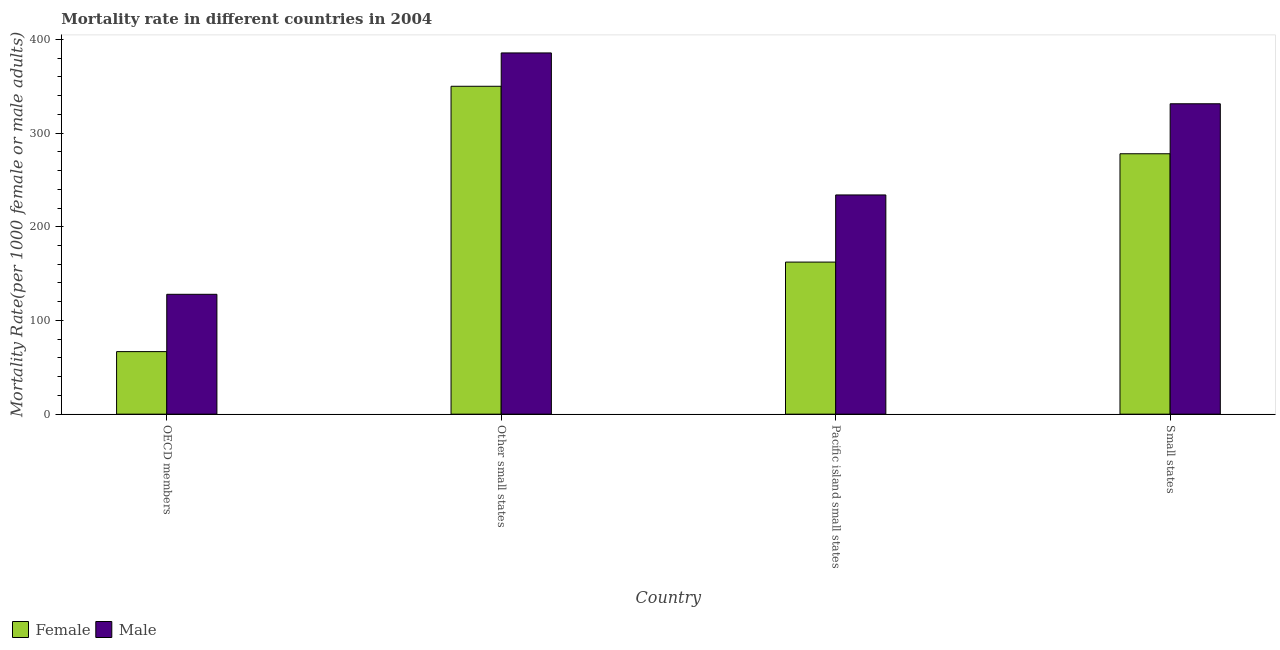How many different coloured bars are there?
Give a very brief answer. 2. How many groups of bars are there?
Provide a succinct answer. 4. Are the number of bars on each tick of the X-axis equal?
Your answer should be very brief. Yes. How many bars are there on the 2nd tick from the left?
Your answer should be compact. 2. How many bars are there on the 1st tick from the right?
Offer a terse response. 2. What is the label of the 4th group of bars from the left?
Your answer should be compact. Small states. What is the male mortality rate in Small states?
Offer a terse response. 331.24. Across all countries, what is the maximum female mortality rate?
Your answer should be very brief. 349.9. Across all countries, what is the minimum female mortality rate?
Your answer should be compact. 66.75. In which country was the female mortality rate maximum?
Ensure brevity in your answer.  Other small states. In which country was the male mortality rate minimum?
Your answer should be very brief. OECD members. What is the total male mortality rate in the graph?
Keep it short and to the point. 1078.55. What is the difference between the male mortality rate in OECD members and that in Small states?
Your answer should be very brief. -203.34. What is the difference between the female mortality rate in Small states and the male mortality rate in Pacific island small states?
Your answer should be very brief. 43.97. What is the average female mortality rate per country?
Make the answer very short. 214.21. What is the difference between the male mortality rate and female mortality rate in Pacific island small states?
Offer a terse response. 71.63. What is the ratio of the female mortality rate in OECD members to that in Pacific island small states?
Give a very brief answer. 0.41. Is the difference between the male mortality rate in Pacific island small states and Small states greater than the difference between the female mortality rate in Pacific island small states and Small states?
Ensure brevity in your answer.  Yes. What is the difference between the highest and the second highest female mortality rate?
Provide a succinct answer. 72.01. What is the difference between the highest and the lowest female mortality rate?
Offer a very short reply. 283.15. In how many countries, is the female mortality rate greater than the average female mortality rate taken over all countries?
Your answer should be very brief. 2. Is the sum of the male mortality rate in Other small states and Small states greater than the maximum female mortality rate across all countries?
Provide a short and direct response. Yes. What does the 1st bar from the right in Pacific island small states represents?
Your response must be concise. Male. Are all the bars in the graph horizontal?
Provide a short and direct response. No. How many countries are there in the graph?
Your response must be concise. 4. Are the values on the major ticks of Y-axis written in scientific E-notation?
Offer a very short reply. No. Does the graph contain grids?
Offer a very short reply. No. Where does the legend appear in the graph?
Your response must be concise. Bottom left. How are the legend labels stacked?
Ensure brevity in your answer.  Horizontal. What is the title of the graph?
Your answer should be very brief. Mortality rate in different countries in 2004. What is the label or title of the Y-axis?
Your answer should be very brief. Mortality Rate(per 1000 female or male adults). What is the Mortality Rate(per 1000 female or male adults) of Female in OECD members?
Your answer should be very brief. 66.75. What is the Mortality Rate(per 1000 female or male adults) of Male in OECD members?
Offer a very short reply. 127.9. What is the Mortality Rate(per 1000 female or male adults) of Female in Other small states?
Your response must be concise. 349.9. What is the Mortality Rate(per 1000 female or male adults) in Male in Other small states?
Your answer should be very brief. 385.48. What is the Mortality Rate(per 1000 female or male adults) of Female in Pacific island small states?
Provide a short and direct response. 162.3. What is the Mortality Rate(per 1000 female or male adults) in Male in Pacific island small states?
Ensure brevity in your answer.  233.93. What is the Mortality Rate(per 1000 female or male adults) in Female in Small states?
Provide a short and direct response. 277.9. What is the Mortality Rate(per 1000 female or male adults) in Male in Small states?
Make the answer very short. 331.24. Across all countries, what is the maximum Mortality Rate(per 1000 female or male adults) in Female?
Offer a very short reply. 349.9. Across all countries, what is the maximum Mortality Rate(per 1000 female or male adults) of Male?
Offer a terse response. 385.48. Across all countries, what is the minimum Mortality Rate(per 1000 female or male adults) of Female?
Provide a short and direct response. 66.75. Across all countries, what is the minimum Mortality Rate(per 1000 female or male adults) in Male?
Keep it short and to the point. 127.9. What is the total Mortality Rate(per 1000 female or male adults) of Female in the graph?
Keep it short and to the point. 856.85. What is the total Mortality Rate(per 1000 female or male adults) in Male in the graph?
Keep it short and to the point. 1078.55. What is the difference between the Mortality Rate(per 1000 female or male adults) of Female in OECD members and that in Other small states?
Make the answer very short. -283.15. What is the difference between the Mortality Rate(per 1000 female or male adults) of Male in OECD members and that in Other small states?
Make the answer very short. -257.58. What is the difference between the Mortality Rate(per 1000 female or male adults) of Female in OECD members and that in Pacific island small states?
Make the answer very short. -95.55. What is the difference between the Mortality Rate(per 1000 female or male adults) in Male in OECD members and that in Pacific island small states?
Your answer should be very brief. -106.03. What is the difference between the Mortality Rate(per 1000 female or male adults) in Female in OECD members and that in Small states?
Provide a succinct answer. -211.15. What is the difference between the Mortality Rate(per 1000 female or male adults) of Male in OECD members and that in Small states?
Provide a succinct answer. -203.34. What is the difference between the Mortality Rate(per 1000 female or male adults) of Female in Other small states and that in Pacific island small states?
Ensure brevity in your answer.  187.61. What is the difference between the Mortality Rate(per 1000 female or male adults) in Male in Other small states and that in Pacific island small states?
Your answer should be compact. 151.55. What is the difference between the Mortality Rate(per 1000 female or male adults) in Female in Other small states and that in Small states?
Provide a short and direct response. 72.01. What is the difference between the Mortality Rate(per 1000 female or male adults) of Male in Other small states and that in Small states?
Give a very brief answer. 54.25. What is the difference between the Mortality Rate(per 1000 female or male adults) in Female in Pacific island small states and that in Small states?
Provide a short and direct response. -115.6. What is the difference between the Mortality Rate(per 1000 female or male adults) of Male in Pacific island small states and that in Small states?
Ensure brevity in your answer.  -97.31. What is the difference between the Mortality Rate(per 1000 female or male adults) of Female in OECD members and the Mortality Rate(per 1000 female or male adults) of Male in Other small states?
Make the answer very short. -318.73. What is the difference between the Mortality Rate(per 1000 female or male adults) of Female in OECD members and the Mortality Rate(per 1000 female or male adults) of Male in Pacific island small states?
Your answer should be very brief. -167.18. What is the difference between the Mortality Rate(per 1000 female or male adults) in Female in OECD members and the Mortality Rate(per 1000 female or male adults) in Male in Small states?
Offer a very short reply. -264.49. What is the difference between the Mortality Rate(per 1000 female or male adults) of Female in Other small states and the Mortality Rate(per 1000 female or male adults) of Male in Pacific island small states?
Your response must be concise. 115.97. What is the difference between the Mortality Rate(per 1000 female or male adults) of Female in Other small states and the Mortality Rate(per 1000 female or male adults) of Male in Small states?
Give a very brief answer. 18.67. What is the difference between the Mortality Rate(per 1000 female or male adults) in Female in Pacific island small states and the Mortality Rate(per 1000 female or male adults) in Male in Small states?
Give a very brief answer. -168.94. What is the average Mortality Rate(per 1000 female or male adults) in Female per country?
Offer a very short reply. 214.21. What is the average Mortality Rate(per 1000 female or male adults) in Male per country?
Your answer should be very brief. 269.64. What is the difference between the Mortality Rate(per 1000 female or male adults) of Female and Mortality Rate(per 1000 female or male adults) of Male in OECD members?
Provide a succinct answer. -61.15. What is the difference between the Mortality Rate(per 1000 female or male adults) in Female and Mortality Rate(per 1000 female or male adults) in Male in Other small states?
Make the answer very short. -35.58. What is the difference between the Mortality Rate(per 1000 female or male adults) of Female and Mortality Rate(per 1000 female or male adults) of Male in Pacific island small states?
Give a very brief answer. -71.63. What is the difference between the Mortality Rate(per 1000 female or male adults) in Female and Mortality Rate(per 1000 female or male adults) in Male in Small states?
Ensure brevity in your answer.  -53.34. What is the ratio of the Mortality Rate(per 1000 female or male adults) in Female in OECD members to that in Other small states?
Offer a terse response. 0.19. What is the ratio of the Mortality Rate(per 1000 female or male adults) of Male in OECD members to that in Other small states?
Your answer should be very brief. 0.33. What is the ratio of the Mortality Rate(per 1000 female or male adults) in Female in OECD members to that in Pacific island small states?
Keep it short and to the point. 0.41. What is the ratio of the Mortality Rate(per 1000 female or male adults) of Male in OECD members to that in Pacific island small states?
Offer a terse response. 0.55. What is the ratio of the Mortality Rate(per 1000 female or male adults) of Female in OECD members to that in Small states?
Your answer should be compact. 0.24. What is the ratio of the Mortality Rate(per 1000 female or male adults) in Male in OECD members to that in Small states?
Ensure brevity in your answer.  0.39. What is the ratio of the Mortality Rate(per 1000 female or male adults) in Female in Other small states to that in Pacific island small states?
Offer a terse response. 2.16. What is the ratio of the Mortality Rate(per 1000 female or male adults) in Male in Other small states to that in Pacific island small states?
Your answer should be compact. 1.65. What is the ratio of the Mortality Rate(per 1000 female or male adults) in Female in Other small states to that in Small states?
Give a very brief answer. 1.26. What is the ratio of the Mortality Rate(per 1000 female or male adults) of Male in Other small states to that in Small states?
Offer a terse response. 1.16. What is the ratio of the Mortality Rate(per 1000 female or male adults) of Female in Pacific island small states to that in Small states?
Keep it short and to the point. 0.58. What is the ratio of the Mortality Rate(per 1000 female or male adults) in Male in Pacific island small states to that in Small states?
Offer a very short reply. 0.71. What is the difference between the highest and the second highest Mortality Rate(per 1000 female or male adults) of Female?
Provide a succinct answer. 72.01. What is the difference between the highest and the second highest Mortality Rate(per 1000 female or male adults) of Male?
Your response must be concise. 54.25. What is the difference between the highest and the lowest Mortality Rate(per 1000 female or male adults) in Female?
Your answer should be compact. 283.15. What is the difference between the highest and the lowest Mortality Rate(per 1000 female or male adults) in Male?
Offer a terse response. 257.58. 